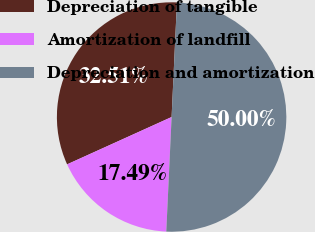Convert chart to OTSL. <chart><loc_0><loc_0><loc_500><loc_500><pie_chart><fcel>Depreciation of tangible<fcel>Amortization of landfill<fcel>Depreciation and amortization<nl><fcel>32.51%<fcel>17.49%<fcel>50.0%<nl></chart> 